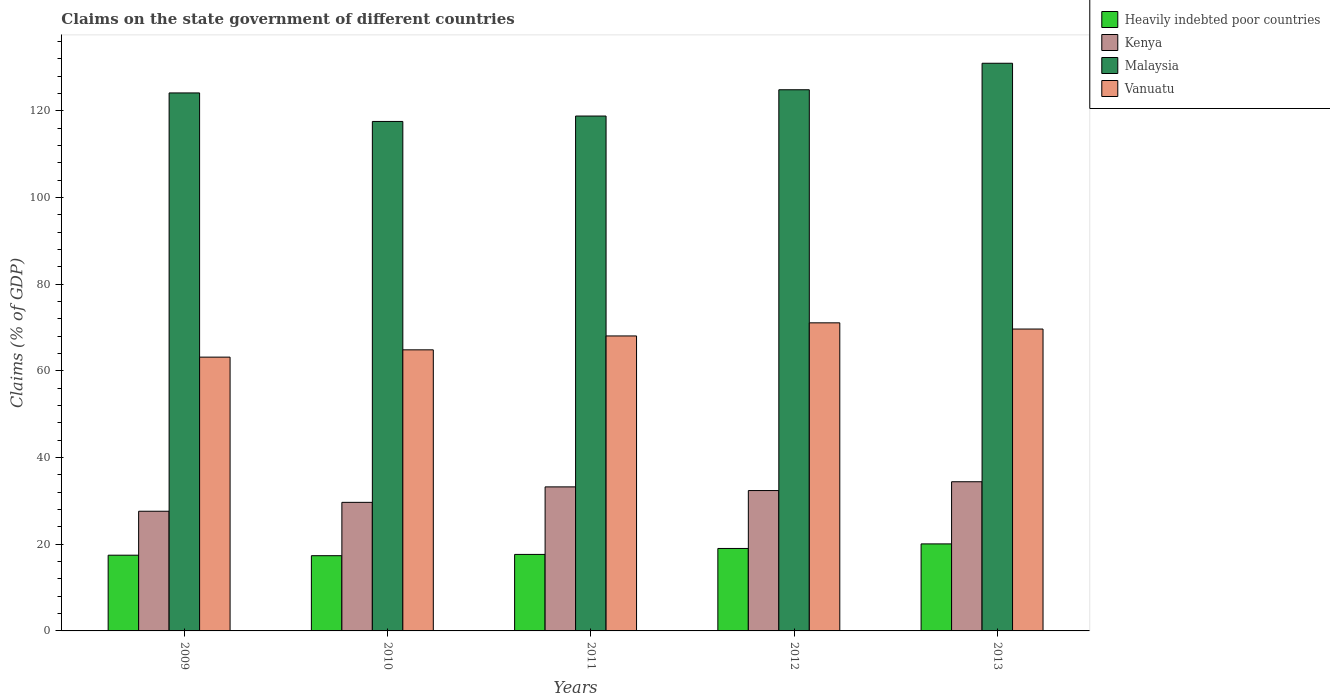Are the number of bars per tick equal to the number of legend labels?
Offer a very short reply. Yes. Are the number of bars on each tick of the X-axis equal?
Your response must be concise. Yes. How many bars are there on the 3rd tick from the right?
Provide a succinct answer. 4. What is the percentage of GDP claimed on the state government in Kenya in 2010?
Offer a very short reply. 29.66. Across all years, what is the maximum percentage of GDP claimed on the state government in Heavily indebted poor countries?
Offer a terse response. 20.08. Across all years, what is the minimum percentage of GDP claimed on the state government in Malaysia?
Offer a terse response. 117.54. In which year was the percentage of GDP claimed on the state government in Malaysia maximum?
Ensure brevity in your answer.  2013. What is the total percentage of GDP claimed on the state government in Heavily indebted poor countries in the graph?
Provide a succinct answer. 91.58. What is the difference between the percentage of GDP claimed on the state government in Vanuatu in 2010 and that in 2013?
Provide a short and direct response. -4.8. What is the difference between the percentage of GDP claimed on the state government in Heavily indebted poor countries in 2011 and the percentage of GDP claimed on the state government in Vanuatu in 2010?
Your answer should be very brief. -47.2. What is the average percentage of GDP claimed on the state government in Malaysia per year?
Provide a short and direct response. 123.26. In the year 2011, what is the difference between the percentage of GDP claimed on the state government in Heavily indebted poor countries and percentage of GDP claimed on the state government in Vanuatu?
Your answer should be compact. -50.4. In how many years, is the percentage of GDP claimed on the state government in Kenya greater than 8 %?
Your answer should be very brief. 5. What is the ratio of the percentage of GDP claimed on the state government in Vanuatu in 2010 to that in 2013?
Your answer should be compact. 0.93. Is the difference between the percentage of GDP claimed on the state government in Heavily indebted poor countries in 2009 and 2010 greater than the difference between the percentage of GDP claimed on the state government in Vanuatu in 2009 and 2010?
Ensure brevity in your answer.  Yes. What is the difference between the highest and the second highest percentage of GDP claimed on the state government in Kenya?
Make the answer very short. 1.19. What is the difference between the highest and the lowest percentage of GDP claimed on the state government in Heavily indebted poor countries?
Keep it short and to the point. 2.72. What does the 2nd bar from the left in 2011 represents?
Offer a terse response. Kenya. What does the 2nd bar from the right in 2013 represents?
Keep it short and to the point. Malaysia. Is it the case that in every year, the sum of the percentage of GDP claimed on the state government in Kenya and percentage of GDP claimed on the state government in Vanuatu is greater than the percentage of GDP claimed on the state government in Heavily indebted poor countries?
Offer a very short reply. Yes. Are all the bars in the graph horizontal?
Provide a short and direct response. No. Are the values on the major ticks of Y-axis written in scientific E-notation?
Your answer should be compact. No. Does the graph contain any zero values?
Provide a succinct answer. No. Does the graph contain grids?
Offer a terse response. No. What is the title of the graph?
Provide a short and direct response. Claims on the state government of different countries. What is the label or title of the X-axis?
Ensure brevity in your answer.  Years. What is the label or title of the Y-axis?
Provide a short and direct response. Claims (% of GDP). What is the Claims (% of GDP) in Heavily indebted poor countries in 2009?
Offer a very short reply. 17.47. What is the Claims (% of GDP) of Kenya in 2009?
Provide a succinct answer. 27.61. What is the Claims (% of GDP) in Malaysia in 2009?
Your response must be concise. 124.12. What is the Claims (% of GDP) of Vanuatu in 2009?
Give a very brief answer. 63.17. What is the Claims (% of GDP) of Heavily indebted poor countries in 2010?
Ensure brevity in your answer.  17.36. What is the Claims (% of GDP) in Kenya in 2010?
Provide a succinct answer. 29.66. What is the Claims (% of GDP) of Malaysia in 2010?
Give a very brief answer. 117.54. What is the Claims (% of GDP) of Vanuatu in 2010?
Offer a very short reply. 64.85. What is the Claims (% of GDP) of Heavily indebted poor countries in 2011?
Your answer should be compact. 17.65. What is the Claims (% of GDP) of Kenya in 2011?
Provide a short and direct response. 33.23. What is the Claims (% of GDP) in Malaysia in 2011?
Offer a very short reply. 118.79. What is the Claims (% of GDP) in Vanuatu in 2011?
Your response must be concise. 68.05. What is the Claims (% of GDP) in Heavily indebted poor countries in 2012?
Offer a terse response. 19.03. What is the Claims (% of GDP) in Kenya in 2012?
Provide a short and direct response. 32.39. What is the Claims (% of GDP) of Malaysia in 2012?
Offer a very short reply. 124.86. What is the Claims (% of GDP) of Vanuatu in 2012?
Make the answer very short. 71.08. What is the Claims (% of GDP) of Heavily indebted poor countries in 2013?
Offer a very short reply. 20.08. What is the Claims (% of GDP) in Kenya in 2013?
Your answer should be compact. 34.42. What is the Claims (% of GDP) in Malaysia in 2013?
Give a very brief answer. 130.97. What is the Claims (% of GDP) in Vanuatu in 2013?
Give a very brief answer. 69.65. Across all years, what is the maximum Claims (% of GDP) of Heavily indebted poor countries?
Your answer should be very brief. 20.08. Across all years, what is the maximum Claims (% of GDP) of Kenya?
Ensure brevity in your answer.  34.42. Across all years, what is the maximum Claims (% of GDP) of Malaysia?
Your response must be concise. 130.97. Across all years, what is the maximum Claims (% of GDP) in Vanuatu?
Your answer should be compact. 71.08. Across all years, what is the minimum Claims (% of GDP) in Heavily indebted poor countries?
Make the answer very short. 17.36. Across all years, what is the minimum Claims (% of GDP) in Kenya?
Ensure brevity in your answer.  27.61. Across all years, what is the minimum Claims (% of GDP) in Malaysia?
Keep it short and to the point. 117.54. Across all years, what is the minimum Claims (% of GDP) of Vanuatu?
Provide a short and direct response. 63.17. What is the total Claims (% of GDP) of Heavily indebted poor countries in the graph?
Provide a short and direct response. 91.58. What is the total Claims (% of GDP) of Kenya in the graph?
Keep it short and to the point. 157.31. What is the total Claims (% of GDP) in Malaysia in the graph?
Give a very brief answer. 616.28. What is the total Claims (% of GDP) of Vanuatu in the graph?
Your response must be concise. 336.8. What is the difference between the Claims (% of GDP) of Heavily indebted poor countries in 2009 and that in 2010?
Provide a short and direct response. 0.12. What is the difference between the Claims (% of GDP) of Kenya in 2009 and that in 2010?
Keep it short and to the point. -2.05. What is the difference between the Claims (% of GDP) of Malaysia in 2009 and that in 2010?
Provide a succinct answer. 6.58. What is the difference between the Claims (% of GDP) of Vanuatu in 2009 and that in 2010?
Make the answer very short. -1.68. What is the difference between the Claims (% of GDP) in Heavily indebted poor countries in 2009 and that in 2011?
Your answer should be compact. -0.18. What is the difference between the Claims (% of GDP) of Kenya in 2009 and that in 2011?
Your answer should be compact. -5.62. What is the difference between the Claims (% of GDP) in Malaysia in 2009 and that in 2011?
Your response must be concise. 5.33. What is the difference between the Claims (% of GDP) of Vanuatu in 2009 and that in 2011?
Offer a very short reply. -4.89. What is the difference between the Claims (% of GDP) in Heavily indebted poor countries in 2009 and that in 2012?
Offer a terse response. -1.55. What is the difference between the Claims (% of GDP) of Kenya in 2009 and that in 2012?
Your answer should be compact. -4.78. What is the difference between the Claims (% of GDP) in Malaysia in 2009 and that in 2012?
Your response must be concise. -0.73. What is the difference between the Claims (% of GDP) of Vanuatu in 2009 and that in 2012?
Ensure brevity in your answer.  -7.91. What is the difference between the Claims (% of GDP) of Heavily indebted poor countries in 2009 and that in 2013?
Provide a succinct answer. -2.6. What is the difference between the Claims (% of GDP) of Kenya in 2009 and that in 2013?
Make the answer very short. -6.81. What is the difference between the Claims (% of GDP) in Malaysia in 2009 and that in 2013?
Offer a very short reply. -6.84. What is the difference between the Claims (% of GDP) in Vanuatu in 2009 and that in 2013?
Provide a short and direct response. -6.48. What is the difference between the Claims (% of GDP) in Heavily indebted poor countries in 2010 and that in 2011?
Give a very brief answer. -0.29. What is the difference between the Claims (% of GDP) of Kenya in 2010 and that in 2011?
Your answer should be compact. -3.57. What is the difference between the Claims (% of GDP) in Malaysia in 2010 and that in 2011?
Your answer should be compact. -1.25. What is the difference between the Claims (% of GDP) of Vanuatu in 2010 and that in 2011?
Keep it short and to the point. -3.21. What is the difference between the Claims (% of GDP) of Heavily indebted poor countries in 2010 and that in 2012?
Provide a short and direct response. -1.67. What is the difference between the Claims (% of GDP) of Kenya in 2010 and that in 2012?
Provide a succinct answer. -2.72. What is the difference between the Claims (% of GDP) in Malaysia in 2010 and that in 2012?
Ensure brevity in your answer.  -7.31. What is the difference between the Claims (% of GDP) in Vanuatu in 2010 and that in 2012?
Keep it short and to the point. -6.23. What is the difference between the Claims (% of GDP) of Heavily indebted poor countries in 2010 and that in 2013?
Provide a short and direct response. -2.72. What is the difference between the Claims (% of GDP) in Kenya in 2010 and that in 2013?
Provide a succinct answer. -4.75. What is the difference between the Claims (% of GDP) of Malaysia in 2010 and that in 2013?
Make the answer very short. -13.42. What is the difference between the Claims (% of GDP) in Vanuatu in 2010 and that in 2013?
Give a very brief answer. -4.8. What is the difference between the Claims (% of GDP) in Heavily indebted poor countries in 2011 and that in 2012?
Make the answer very short. -1.38. What is the difference between the Claims (% of GDP) in Kenya in 2011 and that in 2012?
Provide a succinct answer. 0.85. What is the difference between the Claims (% of GDP) in Malaysia in 2011 and that in 2012?
Offer a terse response. -6.06. What is the difference between the Claims (% of GDP) in Vanuatu in 2011 and that in 2012?
Provide a succinct answer. -3.02. What is the difference between the Claims (% of GDP) of Heavily indebted poor countries in 2011 and that in 2013?
Your response must be concise. -2.43. What is the difference between the Claims (% of GDP) of Kenya in 2011 and that in 2013?
Your response must be concise. -1.19. What is the difference between the Claims (% of GDP) of Malaysia in 2011 and that in 2013?
Provide a short and direct response. -12.18. What is the difference between the Claims (% of GDP) of Vanuatu in 2011 and that in 2013?
Offer a terse response. -1.59. What is the difference between the Claims (% of GDP) of Heavily indebted poor countries in 2012 and that in 2013?
Offer a very short reply. -1.05. What is the difference between the Claims (% of GDP) of Kenya in 2012 and that in 2013?
Give a very brief answer. -2.03. What is the difference between the Claims (% of GDP) in Malaysia in 2012 and that in 2013?
Your answer should be very brief. -6.11. What is the difference between the Claims (% of GDP) of Vanuatu in 2012 and that in 2013?
Offer a terse response. 1.43. What is the difference between the Claims (% of GDP) of Heavily indebted poor countries in 2009 and the Claims (% of GDP) of Kenya in 2010?
Make the answer very short. -12.19. What is the difference between the Claims (% of GDP) of Heavily indebted poor countries in 2009 and the Claims (% of GDP) of Malaysia in 2010?
Offer a terse response. -100.07. What is the difference between the Claims (% of GDP) of Heavily indebted poor countries in 2009 and the Claims (% of GDP) of Vanuatu in 2010?
Keep it short and to the point. -47.38. What is the difference between the Claims (% of GDP) in Kenya in 2009 and the Claims (% of GDP) in Malaysia in 2010?
Ensure brevity in your answer.  -89.93. What is the difference between the Claims (% of GDP) in Kenya in 2009 and the Claims (% of GDP) in Vanuatu in 2010?
Provide a short and direct response. -37.24. What is the difference between the Claims (% of GDP) of Malaysia in 2009 and the Claims (% of GDP) of Vanuatu in 2010?
Keep it short and to the point. 59.27. What is the difference between the Claims (% of GDP) in Heavily indebted poor countries in 2009 and the Claims (% of GDP) in Kenya in 2011?
Provide a short and direct response. -15.76. What is the difference between the Claims (% of GDP) of Heavily indebted poor countries in 2009 and the Claims (% of GDP) of Malaysia in 2011?
Make the answer very short. -101.32. What is the difference between the Claims (% of GDP) in Heavily indebted poor countries in 2009 and the Claims (% of GDP) in Vanuatu in 2011?
Provide a short and direct response. -50.58. What is the difference between the Claims (% of GDP) of Kenya in 2009 and the Claims (% of GDP) of Malaysia in 2011?
Your response must be concise. -91.18. What is the difference between the Claims (% of GDP) in Kenya in 2009 and the Claims (% of GDP) in Vanuatu in 2011?
Your answer should be compact. -40.44. What is the difference between the Claims (% of GDP) in Malaysia in 2009 and the Claims (% of GDP) in Vanuatu in 2011?
Keep it short and to the point. 56.07. What is the difference between the Claims (% of GDP) of Heavily indebted poor countries in 2009 and the Claims (% of GDP) of Kenya in 2012?
Keep it short and to the point. -14.91. What is the difference between the Claims (% of GDP) in Heavily indebted poor countries in 2009 and the Claims (% of GDP) in Malaysia in 2012?
Ensure brevity in your answer.  -107.38. What is the difference between the Claims (% of GDP) in Heavily indebted poor countries in 2009 and the Claims (% of GDP) in Vanuatu in 2012?
Provide a succinct answer. -53.61. What is the difference between the Claims (% of GDP) in Kenya in 2009 and the Claims (% of GDP) in Malaysia in 2012?
Offer a very short reply. -97.24. What is the difference between the Claims (% of GDP) of Kenya in 2009 and the Claims (% of GDP) of Vanuatu in 2012?
Your answer should be compact. -43.47. What is the difference between the Claims (% of GDP) in Malaysia in 2009 and the Claims (% of GDP) in Vanuatu in 2012?
Provide a succinct answer. 53.04. What is the difference between the Claims (% of GDP) in Heavily indebted poor countries in 2009 and the Claims (% of GDP) in Kenya in 2013?
Your answer should be very brief. -16.95. What is the difference between the Claims (% of GDP) in Heavily indebted poor countries in 2009 and the Claims (% of GDP) in Malaysia in 2013?
Provide a succinct answer. -113.5. What is the difference between the Claims (% of GDP) in Heavily indebted poor countries in 2009 and the Claims (% of GDP) in Vanuatu in 2013?
Provide a short and direct response. -52.18. What is the difference between the Claims (% of GDP) in Kenya in 2009 and the Claims (% of GDP) in Malaysia in 2013?
Give a very brief answer. -103.36. What is the difference between the Claims (% of GDP) of Kenya in 2009 and the Claims (% of GDP) of Vanuatu in 2013?
Your answer should be compact. -42.04. What is the difference between the Claims (% of GDP) in Malaysia in 2009 and the Claims (% of GDP) in Vanuatu in 2013?
Your answer should be very brief. 54.47. What is the difference between the Claims (% of GDP) of Heavily indebted poor countries in 2010 and the Claims (% of GDP) of Kenya in 2011?
Give a very brief answer. -15.88. What is the difference between the Claims (% of GDP) in Heavily indebted poor countries in 2010 and the Claims (% of GDP) in Malaysia in 2011?
Your answer should be very brief. -101.44. What is the difference between the Claims (% of GDP) in Heavily indebted poor countries in 2010 and the Claims (% of GDP) in Vanuatu in 2011?
Give a very brief answer. -50.7. What is the difference between the Claims (% of GDP) of Kenya in 2010 and the Claims (% of GDP) of Malaysia in 2011?
Provide a succinct answer. -89.13. What is the difference between the Claims (% of GDP) of Kenya in 2010 and the Claims (% of GDP) of Vanuatu in 2011?
Provide a short and direct response. -38.39. What is the difference between the Claims (% of GDP) of Malaysia in 2010 and the Claims (% of GDP) of Vanuatu in 2011?
Offer a terse response. 49.49. What is the difference between the Claims (% of GDP) of Heavily indebted poor countries in 2010 and the Claims (% of GDP) of Kenya in 2012?
Provide a short and direct response. -15.03. What is the difference between the Claims (% of GDP) in Heavily indebted poor countries in 2010 and the Claims (% of GDP) in Malaysia in 2012?
Provide a succinct answer. -107.5. What is the difference between the Claims (% of GDP) in Heavily indebted poor countries in 2010 and the Claims (% of GDP) in Vanuatu in 2012?
Your answer should be very brief. -53.72. What is the difference between the Claims (% of GDP) of Kenya in 2010 and the Claims (% of GDP) of Malaysia in 2012?
Your answer should be very brief. -95.19. What is the difference between the Claims (% of GDP) in Kenya in 2010 and the Claims (% of GDP) in Vanuatu in 2012?
Provide a succinct answer. -41.41. What is the difference between the Claims (% of GDP) of Malaysia in 2010 and the Claims (% of GDP) of Vanuatu in 2012?
Your answer should be very brief. 46.47. What is the difference between the Claims (% of GDP) of Heavily indebted poor countries in 2010 and the Claims (% of GDP) of Kenya in 2013?
Offer a terse response. -17.06. What is the difference between the Claims (% of GDP) of Heavily indebted poor countries in 2010 and the Claims (% of GDP) of Malaysia in 2013?
Provide a short and direct response. -113.61. What is the difference between the Claims (% of GDP) in Heavily indebted poor countries in 2010 and the Claims (% of GDP) in Vanuatu in 2013?
Make the answer very short. -52.29. What is the difference between the Claims (% of GDP) of Kenya in 2010 and the Claims (% of GDP) of Malaysia in 2013?
Provide a short and direct response. -101.3. What is the difference between the Claims (% of GDP) of Kenya in 2010 and the Claims (% of GDP) of Vanuatu in 2013?
Provide a short and direct response. -39.98. What is the difference between the Claims (% of GDP) in Malaysia in 2010 and the Claims (% of GDP) in Vanuatu in 2013?
Keep it short and to the point. 47.89. What is the difference between the Claims (% of GDP) in Heavily indebted poor countries in 2011 and the Claims (% of GDP) in Kenya in 2012?
Offer a terse response. -14.74. What is the difference between the Claims (% of GDP) in Heavily indebted poor countries in 2011 and the Claims (% of GDP) in Malaysia in 2012?
Your response must be concise. -107.2. What is the difference between the Claims (% of GDP) in Heavily indebted poor countries in 2011 and the Claims (% of GDP) in Vanuatu in 2012?
Keep it short and to the point. -53.43. What is the difference between the Claims (% of GDP) in Kenya in 2011 and the Claims (% of GDP) in Malaysia in 2012?
Provide a succinct answer. -91.62. What is the difference between the Claims (% of GDP) in Kenya in 2011 and the Claims (% of GDP) in Vanuatu in 2012?
Your answer should be very brief. -37.84. What is the difference between the Claims (% of GDP) of Malaysia in 2011 and the Claims (% of GDP) of Vanuatu in 2012?
Provide a short and direct response. 47.71. What is the difference between the Claims (% of GDP) of Heavily indebted poor countries in 2011 and the Claims (% of GDP) of Kenya in 2013?
Make the answer very short. -16.77. What is the difference between the Claims (% of GDP) of Heavily indebted poor countries in 2011 and the Claims (% of GDP) of Malaysia in 2013?
Provide a short and direct response. -113.32. What is the difference between the Claims (% of GDP) in Heavily indebted poor countries in 2011 and the Claims (% of GDP) in Vanuatu in 2013?
Your answer should be compact. -52. What is the difference between the Claims (% of GDP) of Kenya in 2011 and the Claims (% of GDP) of Malaysia in 2013?
Give a very brief answer. -97.73. What is the difference between the Claims (% of GDP) in Kenya in 2011 and the Claims (% of GDP) in Vanuatu in 2013?
Your response must be concise. -36.42. What is the difference between the Claims (% of GDP) of Malaysia in 2011 and the Claims (% of GDP) of Vanuatu in 2013?
Give a very brief answer. 49.14. What is the difference between the Claims (% of GDP) of Heavily indebted poor countries in 2012 and the Claims (% of GDP) of Kenya in 2013?
Make the answer very short. -15.39. What is the difference between the Claims (% of GDP) in Heavily indebted poor countries in 2012 and the Claims (% of GDP) in Malaysia in 2013?
Your response must be concise. -111.94. What is the difference between the Claims (% of GDP) in Heavily indebted poor countries in 2012 and the Claims (% of GDP) in Vanuatu in 2013?
Provide a succinct answer. -50.62. What is the difference between the Claims (% of GDP) of Kenya in 2012 and the Claims (% of GDP) of Malaysia in 2013?
Your response must be concise. -98.58. What is the difference between the Claims (% of GDP) of Kenya in 2012 and the Claims (% of GDP) of Vanuatu in 2013?
Keep it short and to the point. -37.26. What is the difference between the Claims (% of GDP) in Malaysia in 2012 and the Claims (% of GDP) in Vanuatu in 2013?
Provide a short and direct response. 55.21. What is the average Claims (% of GDP) in Heavily indebted poor countries per year?
Provide a succinct answer. 18.32. What is the average Claims (% of GDP) of Kenya per year?
Give a very brief answer. 31.46. What is the average Claims (% of GDP) of Malaysia per year?
Provide a short and direct response. 123.26. What is the average Claims (% of GDP) of Vanuatu per year?
Keep it short and to the point. 67.36. In the year 2009, what is the difference between the Claims (% of GDP) in Heavily indebted poor countries and Claims (% of GDP) in Kenya?
Ensure brevity in your answer.  -10.14. In the year 2009, what is the difference between the Claims (% of GDP) in Heavily indebted poor countries and Claims (% of GDP) in Malaysia?
Keep it short and to the point. -106.65. In the year 2009, what is the difference between the Claims (% of GDP) of Heavily indebted poor countries and Claims (% of GDP) of Vanuatu?
Keep it short and to the point. -45.7. In the year 2009, what is the difference between the Claims (% of GDP) in Kenya and Claims (% of GDP) in Malaysia?
Keep it short and to the point. -96.51. In the year 2009, what is the difference between the Claims (% of GDP) in Kenya and Claims (% of GDP) in Vanuatu?
Your answer should be very brief. -35.56. In the year 2009, what is the difference between the Claims (% of GDP) in Malaysia and Claims (% of GDP) in Vanuatu?
Offer a very short reply. 60.95. In the year 2010, what is the difference between the Claims (% of GDP) in Heavily indebted poor countries and Claims (% of GDP) in Kenya?
Your answer should be very brief. -12.31. In the year 2010, what is the difference between the Claims (% of GDP) of Heavily indebted poor countries and Claims (% of GDP) of Malaysia?
Your response must be concise. -100.19. In the year 2010, what is the difference between the Claims (% of GDP) of Heavily indebted poor countries and Claims (% of GDP) of Vanuatu?
Make the answer very short. -47.49. In the year 2010, what is the difference between the Claims (% of GDP) of Kenya and Claims (% of GDP) of Malaysia?
Provide a short and direct response. -87.88. In the year 2010, what is the difference between the Claims (% of GDP) of Kenya and Claims (% of GDP) of Vanuatu?
Your answer should be compact. -35.18. In the year 2010, what is the difference between the Claims (% of GDP) in Malaysia and Claims (% of GDP) in Vanuatu?
Your answer should be very brief. 52.69. In the year 2011, what is the difference between the Claims (% of GDP) of Heavily indebted poor countries and Claims (% of GDP) of Kenya?
Offer a terse response. -15.58. In the year 2011, what is the difference between the Claims (% of GDP) in Heavily indebted poor countries and Claims (% of GDP) in Malaysia?
Your answer should be very brief. -101.14. In the year 2011, what is the difference between the Claims (% of GDP) of Heavily indebted poor countries and Claims (% of GDP) of Vanuatu?
Your answer should be very brief. -50.4. In the year 2011, what is the difference between the Claims (% of GDP) in Kenya and Claims (% of GDP) in Malaysia?
Keep it short and to the point. -85.56. In the year 2011, what is the difference between the Claims (% of GDP) of Kenya and Claims (% of GDP) of Vanuatu?
Provide a succinct answer. -34.82. In the year 2011, what is the difference between the Claims (% of GDP) of Malaysia and Claims (% of GDP) of Vanuatu?
Your answer should be compact. 50.74. In the year 2012, what is the difference between the Claims (% of GDP) in Heavily indebted poor countries and Claims (% of GDP) in Kenya?
Provide a succinct answer. -13.36. In the year 2012, what is the difference between the Claims (% of GDP) in Heavily indebted poor countries and Claims (% of GDP) in Malaysia?
Your answer should be compact. -105.83. In the year 2012, what is the difference between the Claims (% of GDP) in Heavily indebted poor countries and Claims (% of GDP) in Vanuatu?
Your answer should be very brief. -52.05. In the year 2012, what is the difference between the Claims (% of GDP) in Kenya and Claims (% of GDP) in Malaysia?
Provide a short and direct response. -92.47. In the year 2012, what is the difference between the Claims (% of GDP) in Kenya and Claims (% of GDP) in Vanuatu?
Offer a very short reply. -38.69. In the year 2012, what is the difference between the Claims (% of GDP) in Malaysia and Claims (% of GDP) in Vanuatu?
Offer a terse response. 53.78. In the year 2013, what is the difference between the Claims (% of GDP) in Heavily indebted poor countries and Claims (% of GDP) in Kenya?
Offer a very short reply. -14.34. In the year 2013, what is the difference between the Claims (% of GDP) of Heavily indebted poor countries and Claims (% of GDP) of Malaysia?
Keep it short and to the point. -110.89. In the year 2013, what is the difference between the Claims (% of GDP) of Heavily indebted poor countries and Claims (% of GDP) of Vanuatu?
Ensure brevity in your answer.  -49.57. In the year 2013, what is the difference between the Claims (% of GDP) in Kenya and Claims (% of GDP) in Malaysia?
Your answer should be compact. -96.55. In the year 2013, what is the difference between the Claims (% of GDP) in Kenya and Claims (% of GDP) in Vanuatu?
Offer a very short reply. -35.23. In the year 2013, what is the difference between the Claims (% of GDP) of Malaysia and Claims (% of GDP) of Vanuatu?
Make the answer very short. 61.32. What is the ratio of the Claims (% of GDP) in Heavily indebted poor countries in 2009 to that in 2010?
Ensure brevity in your answer.  1.01. What is the ratio of the Claims (% of GDP) of Kenya in 2009 to that in 2010?
Ensure brevity in your answer.  0.93. What is the ratio of the Claims (% of GDP) in Malaysia in 2009 to that in 2010?
Provide a succinct answer. 1.06. What is the ratio of the Claims (% of GDP) of Vanuatu in 2009 to that in 2010?
Provide a short and direct response. 0.97. What is the ratio of the Claims (% of GDP) of Heavily indebted poor countries in 2009 to that in 2011?
Your answer should be compact. 0.99. What is the ratio of the Claims (% of GDP) of Kenya in 2009 to that in 2011?
Your response must be concise. 0.83. What is the ratio of the Claims (% of GDP) of Malaysia in 2009 to that in 2011?
Your answer should be compact. 1.04. What is the ratio of the Claims (% of GDP) in Vanuatu in 2009 to that in 2011?
Ensure brevity in your answer.  0.93. What is the ratio of the Claims (% of GDP) of Heavily indebted poor countries in 2009 to that in 2012?
Your response must be concise. 0.92. What is the ratio of the Claims (% of GDP) in Kenya in 2009 to that in 2012?
Your answer should be compact. 0.85. What is the ratio of the Claims (% of GDP) of Vanuatu in 2009 to that in 2012?
Ensure brevity in your answer.  0.89. What is the ratio of the Claims (% of GDP) in Heavily indebted poor countries in 2009 to that in 2013?
Your answer should be compact. 0.87. What is the ratio of the Claims (% of GDP) of Kenya in 2009 to that in 2013?
Your response must be concise. 0.8. What is the ratio of the Claims (% of GDP) in Malaysia in 2009 to that in 2013?
Offer a very short reply. 0.95. What is the ratio of the Claims (% of GDP) of Vanuatu in 2009 to that in 2013?
Offer a very short reply. 0.91. What is the ratio of the Claims (% of GDP) of Heavily indebted poor countries in 2010 to that in 2011?
Offer a very short reply. 0.98. What is the ratio of the Claims (% of GDP) of Kenya in 2010 to that in 2011?
Provide a short and direct response. 0.89. What is the ratio of the Claims (% of GDP) in Vanuatu in 2010 to that in 2011?
Provide a succinct answer. 0.95. What is the ratio of the Claims (% of GDP) in Heavily indebted poor countries in 2010 to that in 2012?
Offer a very short reply. 0.91. What is the ratio of the Claims (% of GDP) of Kenya in 2010 to that in 2012?
Make the answer very short. 0.92. What is the ratio of the Claims (% of GDP) of Malaysia in 2010 to that in 2012?
Your response must be concise. 0.94. What is the ratio of the Claims (% of GDP) of Vanuatu in 2010 to that in 2012?
Offer a terse response. 0.91. What is the ratio of the Claims (% of GDP) of Heavily indebted poor countries in 2010 to that in 2013?
Your answer should be compact. 0.86. What is the ratio of the Claims (% of GDP) in Kenya in 2010 to that in 2013?
Provide a short and direct response. 0.86. What is the ratio of the Claims (% of GDP) of Malaysia in 2010 to that in 2013?
Give a very brief answer. 0.9. What is the ratio of the Claims (% of GDP) in Vanuatu in 2010 to that in 2013?
Provide a short and direct response. 0.93. What is the ratio of the Claims (% of GDP) in Heavily indebted poor countries in 2011 to that in 2012?
Provide a succinct answer. 0.93. What is the ratio of the Claims (% of GDP) of Kenya in 2011 to that in 2012?
Offer a terse response. 1.03. What is the ratio of the Claims (% of GDP) of Malaysia in 2011 to that in 2012?
Ensure brevity in your answer.  0.95. What is the ratio of the Claims (% of GDP) of Vanuatu in 2011 to that in 2012?
Your answer should be compact. 0.96. What is the ratio of the Claims (% of GDP) in Heavily indebted poor countries in 2011 to that in 2013?
Give a very brief answer. 0.88. What is the ratio of the Claims (% of GDP) of Kenya in 2011 to that in 2013?
Ensure brevity in your answer.  0.97. What is the ratio of the Claims (% of GDP) of Malaysia in 2011 to that in 2013?
Your response must be concise. 0.91. What is the ratio of the Claims (% of GDP) of Vanuatu in 2011 to that in 2013?
Offer a terse response. 0.98. What is the ratio of the Claims (% of GDP) of Heavily indebted poor countries in 2012 to that in 2013?
Keep it short and to the point. 0.95. What is the ratio of the Claims (% of GDP) of Kenya in 2012 to that in 2013?
Your response must be concise. 0.94. What is the ratio of the Claims (% of GDP) in Malaysia in 2012 to that in 2013?
Your response must be concise. 0.95. What is the ratio of the Claims (% of GDP) of Vanuatu in 2012 to that in 2013?
Your response must be concise. 1.02. What is the difference between the highest and the second highest Claims (% of GDP) of Heavily indebted poor countries?
Your response must be concise. 1.05. What is the difference between the highest and the second highest Claims (% of GDP) of Kenya?
Give a very brief answer. 1.19. What is the difference between the highest and the second highest Claims (% of GDP) in Malaysia?
Your answer should be very brief. 6.11. What is the difference between the highest and the second highest Claims (% of GDP) in Vanuatu?
Your answer should be compact. 1.43. What is the difference between the highest and the lowest Claims (% of GDP) of Heavily indebted poor countries?
Keep it short and to the point. 2.72. What is the difference between the highest and the lowest Claims (% of GDP) in Kenya?
Your answer should be very brief. 6.81. What is the difference between the highest and the lowest Claims (% of GDP) in Malaysia?
Offer a very short reply. 13.42. What is the difference between the highest and the lowest Claims (% of GDP) of Vanuatu?
Make the answer very short. 7.91. 